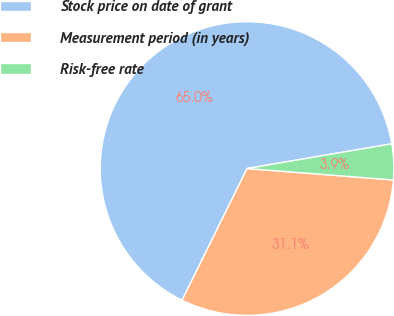Convert chart. <chart><loc_0><loc_0><loc_500><loc_500><pie_chart><fcel>Stock price on date of grant<fcel>Measurement period (in years)<fcel>Risk-free rate<nl><fcel>65.01%<fcel>31.06%<fcel>3.93%<nl></chart> 